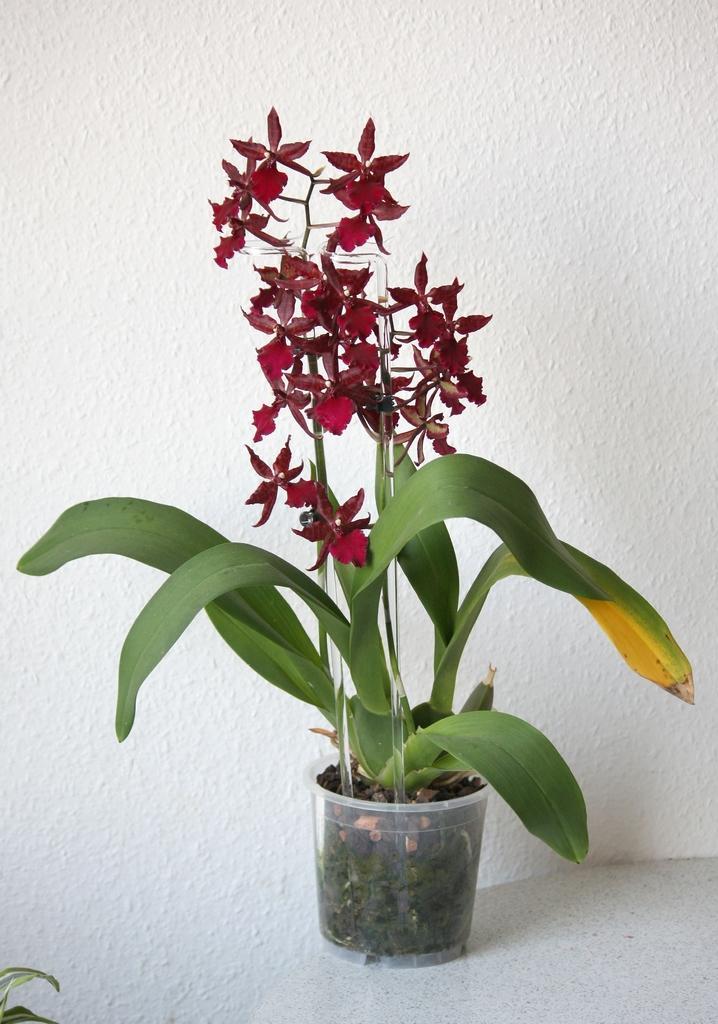How would you summarize this image in a sentence or two? In this image there are flower pots. In the background of the image there is a wall. 